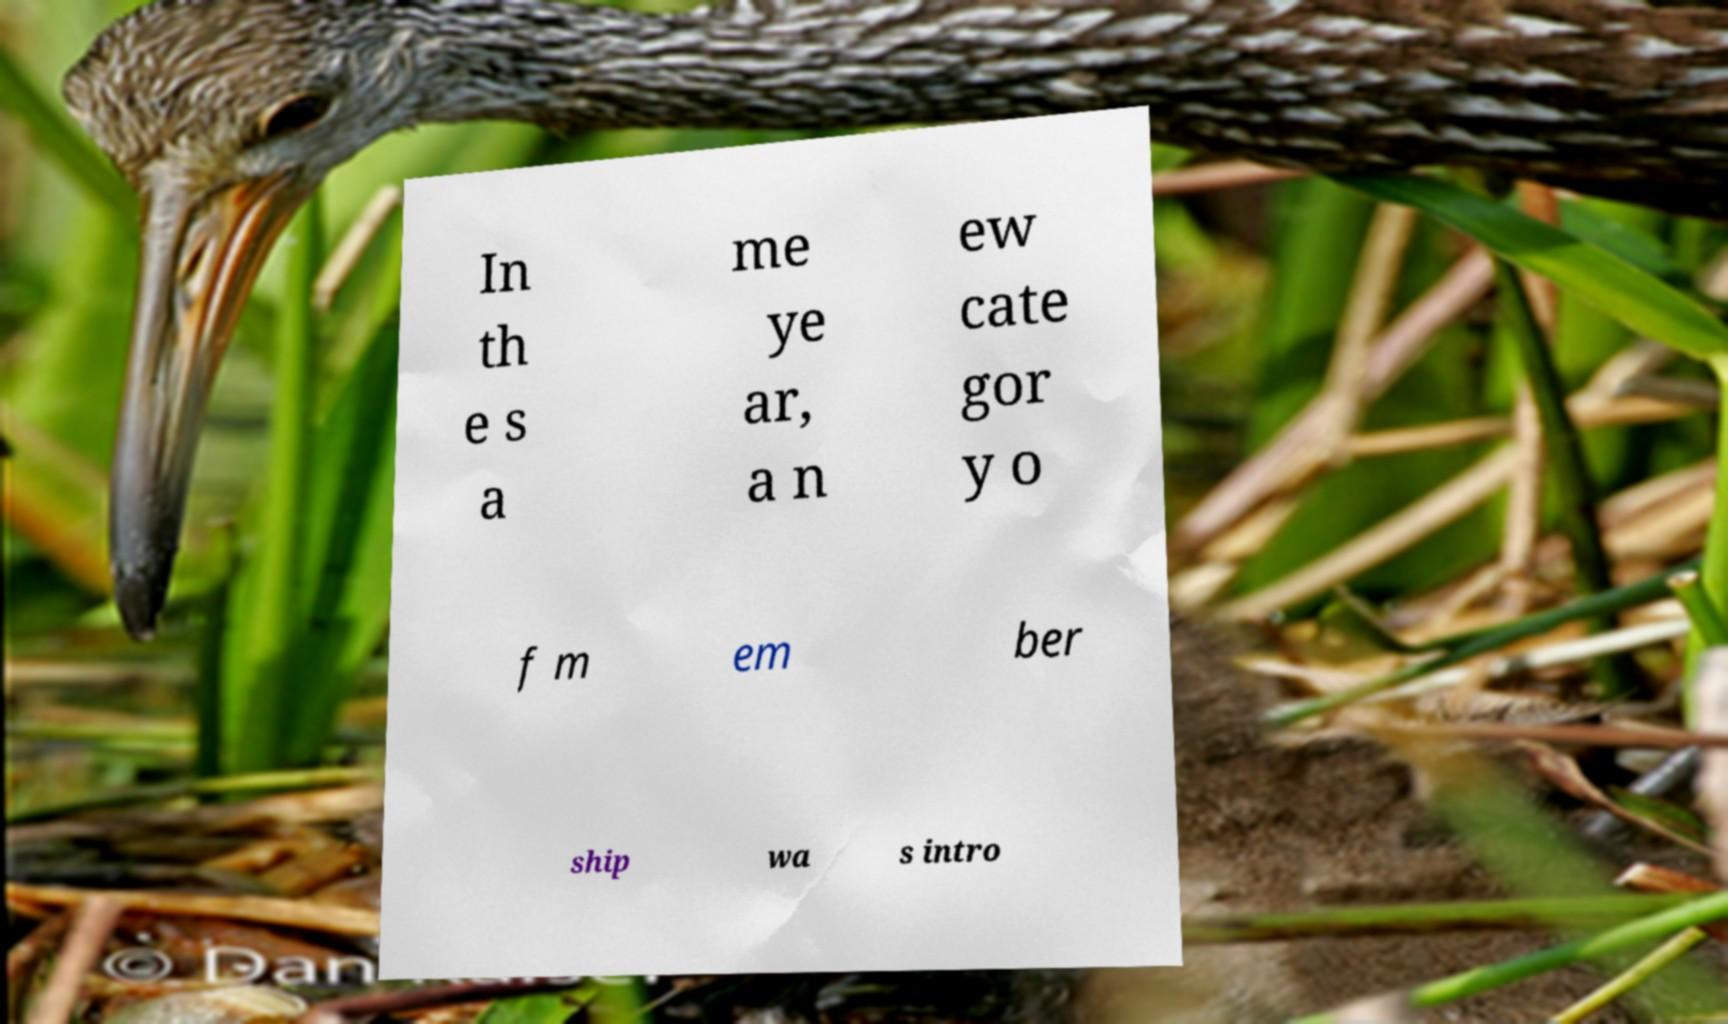Please identify and transcribe the text found in this image. In th e s a me ye ar, a n ew cate gor y o f m em ber ship wa s intro 